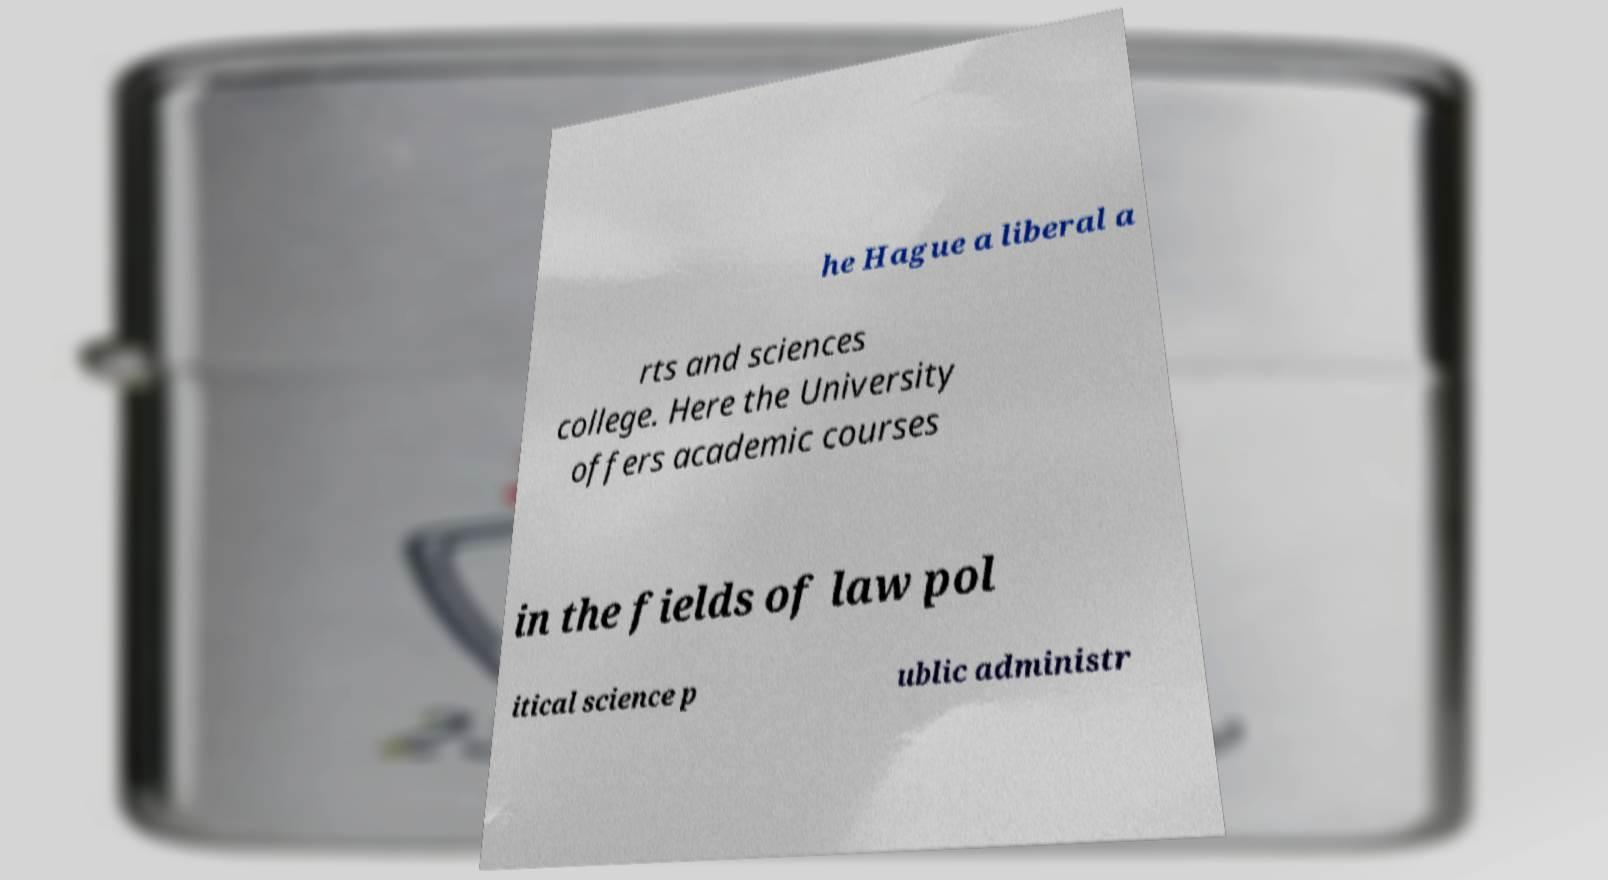For documentation purposes, I need the text within this image transcribed. Could you provide that? he Hague a liberal a rts and sciences college. Here the University offers academic courses in the fields of law pol itical science p ublic administr 